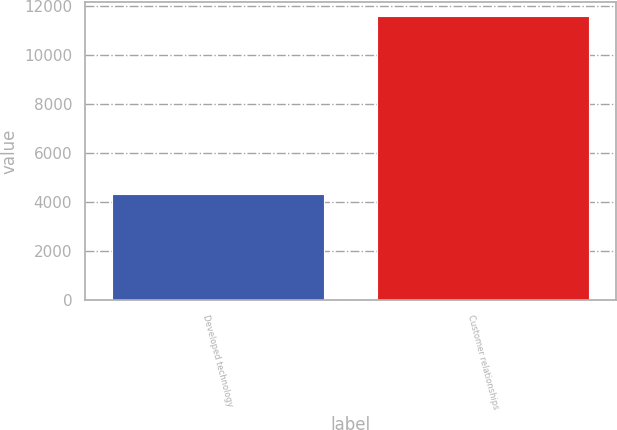Convert chart. <chart><loc_0><loc_0><loc_500><loc_500><bar_chart><fcel>Developed technology<fcel>Customer relationships<nl><fcel>4317<fcel>11560<nl></chart> 